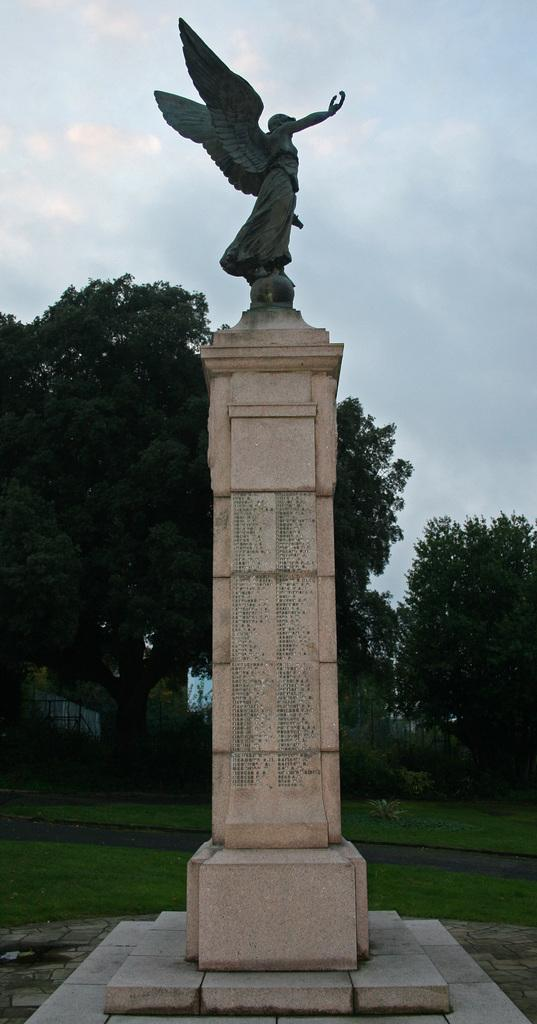What is the main subject in the image? There is a statue on a structure in the image. What can be seen in the background of the image? There are trees, plants, and grassy land in the background of the image. What is visible at the top of the image? The sky is visible at the top of the image. What can be observed in the sky? Clouds are present in the sky. What type of pear can be seen rolling on the stove in the image? There is no pear or stove present in the image. 